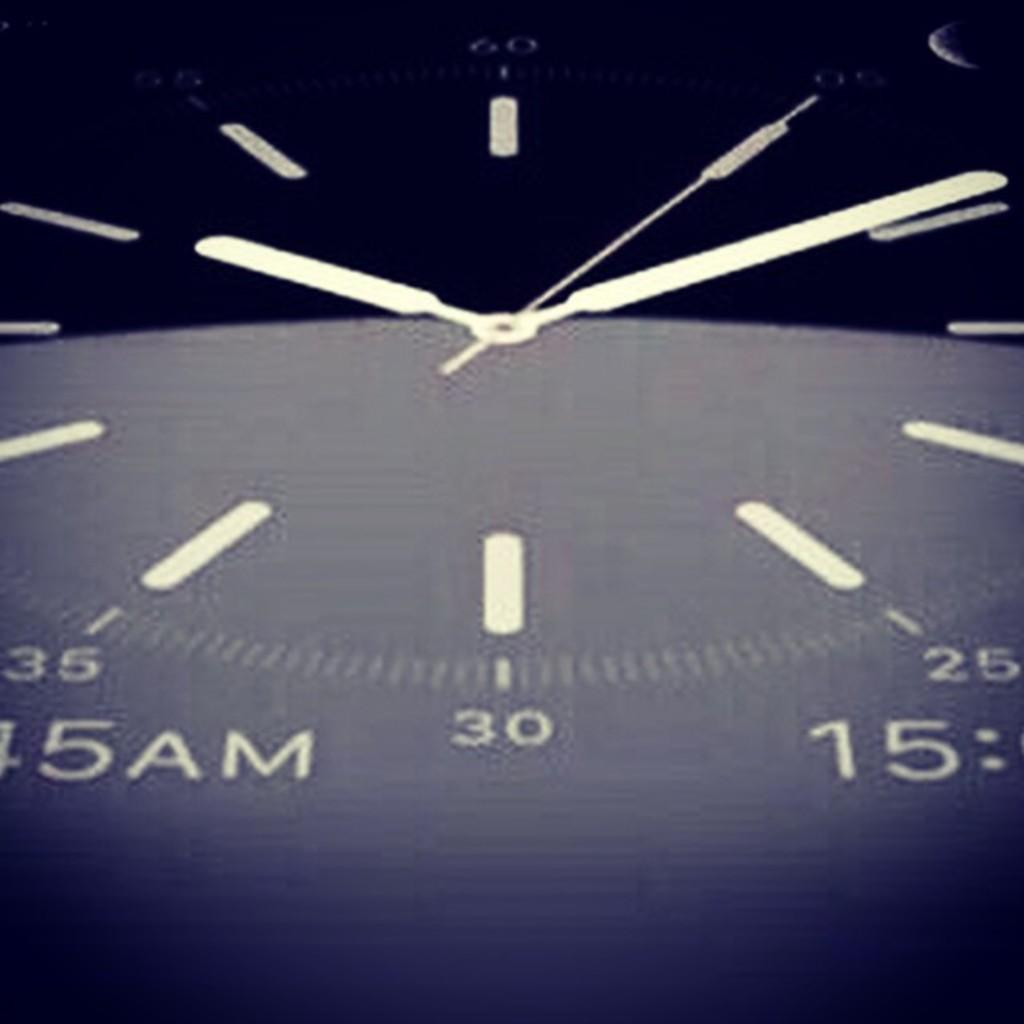<image>
Provide a brief description of the given image. A blue analog clock face says 5 AM. 